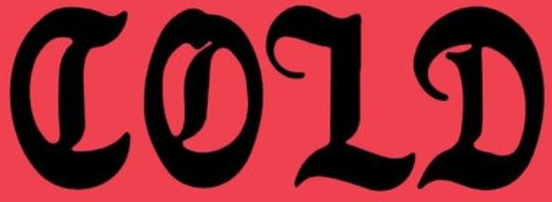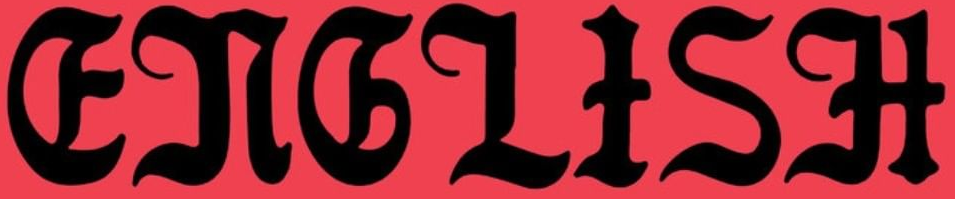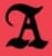Read the text from these images in sequence, separated by a semicolon. COLD; ENGLISH; A 